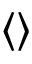Convert formula to latex. <formula><loc_0><loc_0><loc_500><loc_500>\langle \rangle</formula> 